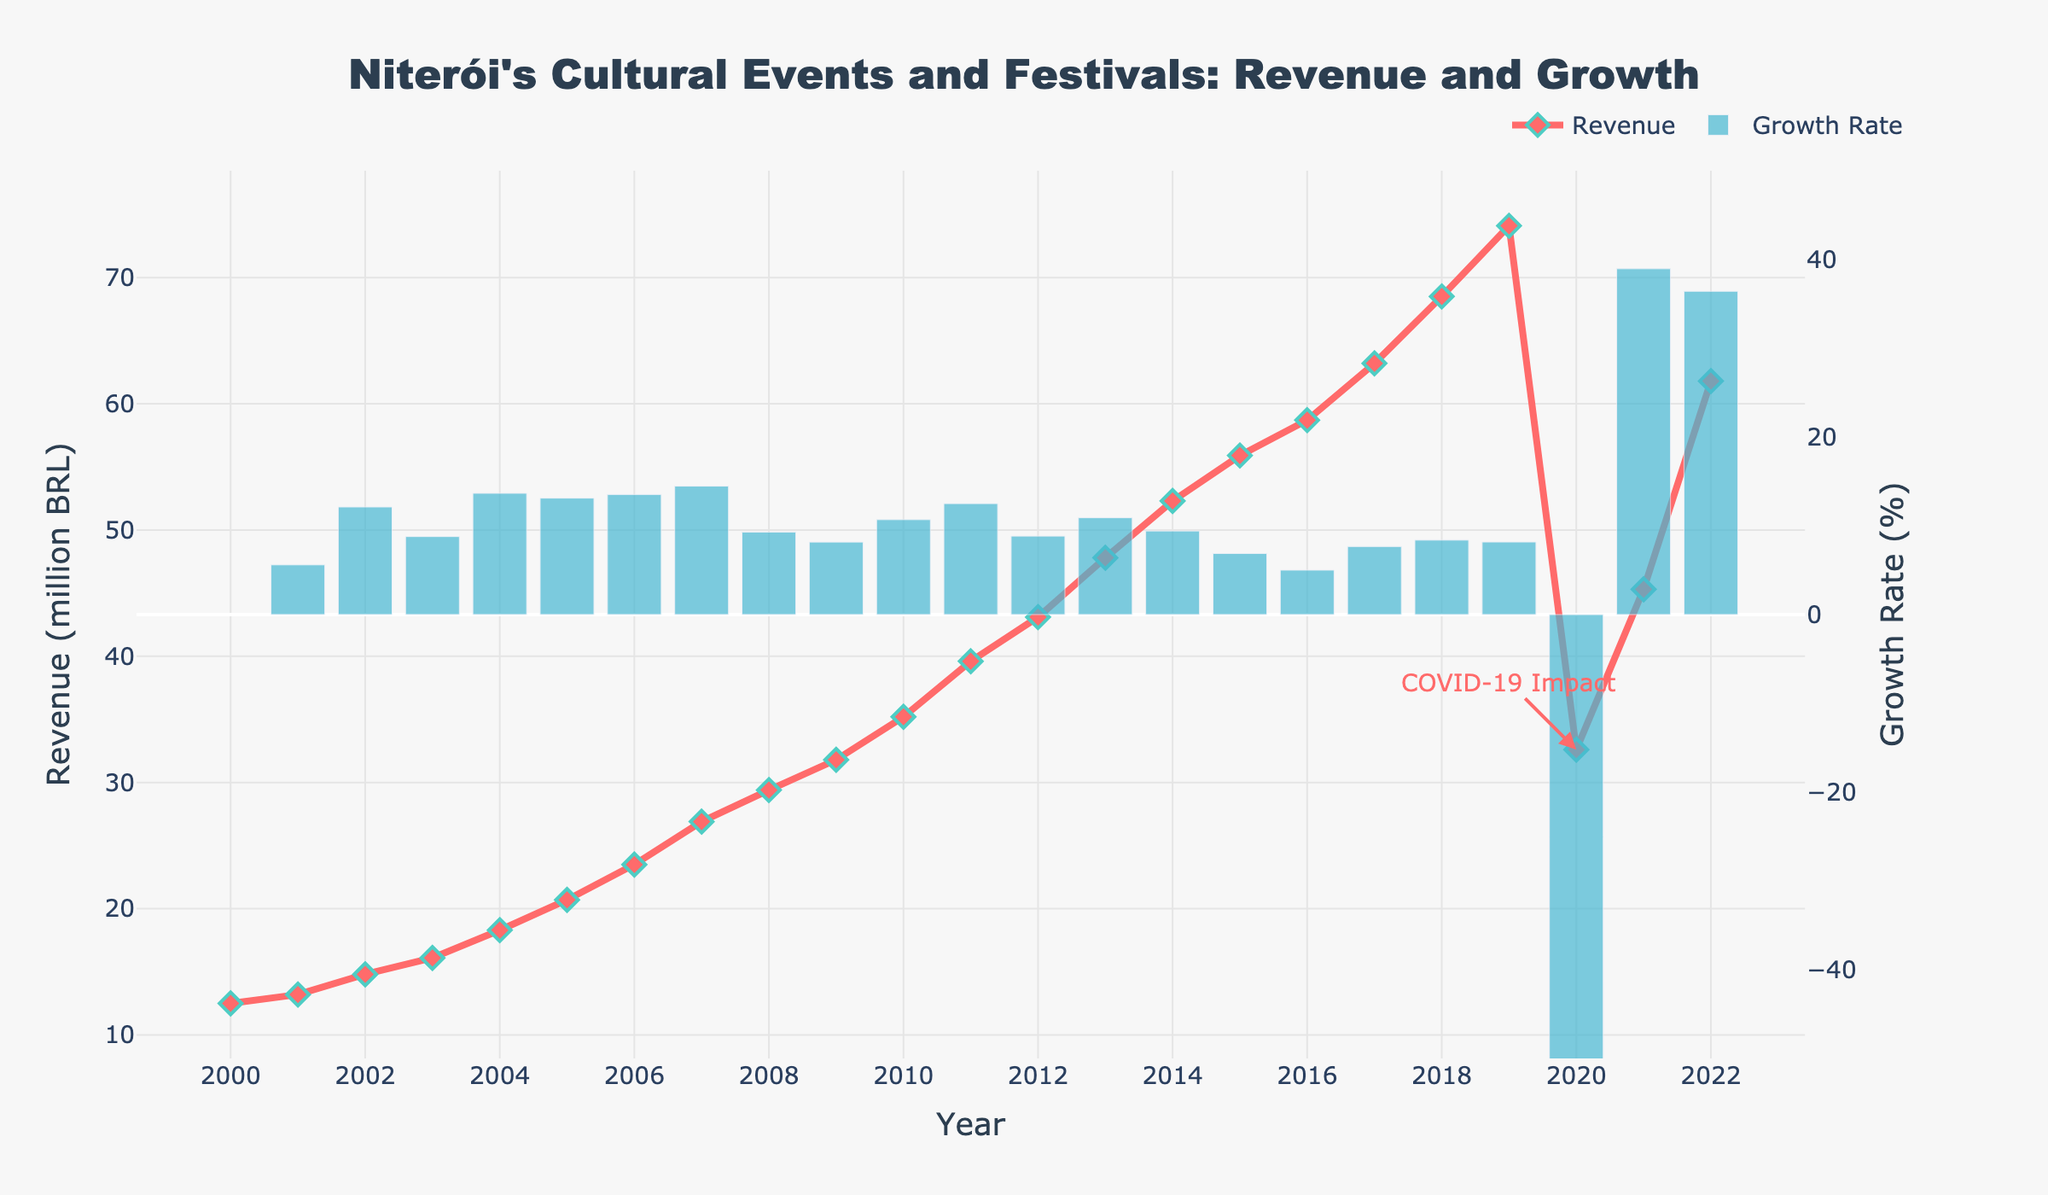What is the general trend in tourism revenue from 2000 to 2019? To identify the trend, observe the line for Revenue from 2000 to 2019. It shows a consistent increase every year.
Answer: Increasing trend What is the revenue difference between the year with the highest and lowest revenue? The highest revenue is in 2019 at 74.1 million BRL, and the lowest is in 2000 at 12.5 million BRL. The difference is 74.1 - 12.5 = 61.6 million BRL.
Answer: 61.6 million BRL How did the COVID-19 pandemic impact tourism revenue in 2020? The annotation on the chart marks 2020 and indicates a significant drop in revenue to 32.6 million BRL. This can be compared to the 74.1 million BRL in 2019, showing a substantial decrease.
Answer: Significant drop Which year experienced the highest growth rate, and what was this rate? By observing the height of the growth rate bars, the highest bar appears in 2021. Checking the value, it confirms a high growth rate for 2021, around 39.3%.
Answer: 2021, 39.3% How does the revenue in 2022 compare to the pre-COVID-19 revenue peak in 2019? The revenue for 2022 is 61.8 million BRL, while for 2019, it was 74.1 million BRL. Comparing these, 2022 is still lower than the pre-COVID-19 peak.
Answer: Lower in 2022 What is the average yearly revenue from 2000 to 2019? Sum the yearly revenues from 2000 to 2019 and divide by the number of years (20 years). The sum is 617.2 million BRL. So the average revenue over these years is 617.2 / 20 = 30.86 million BRL.
Answer: 30.86 million BRL In which year between 2000 to 2009 did the revenue growth occur most significantly? Look at the heights of the growth rate bars between 2000-2009. The highest growth rate bar appears between 2005-2006, indicating a notable increase in that period.
Answer: 2006 What is the impact of the year 2020 on the overall revenue trend? Identify the years before and after 2020. Revenue was increasing until 2019, then significantly dropped in 2020, breaking the upward trend. After that, it rises again but has not yet reached the 2019 level.
Answer: Interrupted increasing trend in 2020 How did the revenue recover in 2021 and 2022 compared to 2020? The revenue in 2020 was 32.6 million BRL. For 2021, it climbed to 45.3 million BRL, and in 2022, it further increased to 61.8 million BRL. Noting the growth from 32.6 to 45.3 and then to 61.8.
Answer: Partially recovered and increasing Which revenue year is closest to the average revenue over the entire period (2000-2022)? The sum of revenues over these years is 953 million BRL, making the average = 953 / 23 ≈ 41.43 million BRL. Closest revenue to this average is in 2012 (43.1 million BRL).
Answer: 2012 